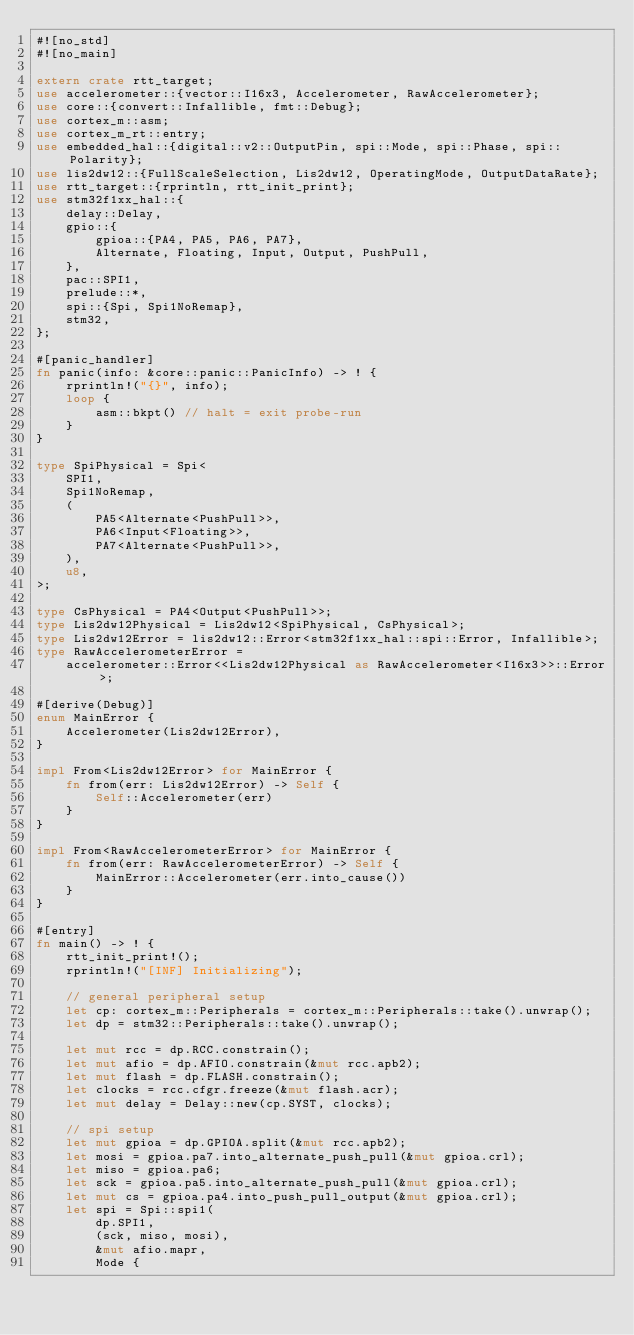Convert code to text. <code><loc_0><loc_0><loc_500><loc_500><_Rust_>#![no_std]
#![no_main]

extern crate rtt_target;
use accelerometer::{vector::I16x3, Accelerometer, RawAccelerometer};
use core::{convert::Infallible, fmt::Debug};
use cortex_m::asm;
use cortex_m_rt::entry;
use embedded_hal::{digital::v2::OutputPin, spi::Mode, spi::Phase, spi::Polarity};
use lis2dw12::{FullScaleSelection, Lis2dw12, OperatingMode, OutputDataRate};
use rtt_target::{rprintln, rtt_init_print};
use stm32f1xx_hal::{
    delay::Delay,
    gpio::{
        gpioa::{PA4, PA5, PA6, PA7},
        Alternate, Floating, Input, Output, PushPull,
    },
    pac::SPI1,
    prelude::*,
    spi::{Spi, Spi1NoRemap},
    stm32,
};

#[panic_handler]
fn panic(info: &core::panic::PanicInfo) -> ! {
    rprintln!("{}", info);
    loop {
        asm::bkpt() // halt = exit probe-run
    }
}

type SpiPhysical = Spi<
    SPI1,
    Spi1NoRemap,
    (
        PA5<Alternate<PushPull>>,
        PA6<Input<Floating>>,
        PA7<Alternate<PushPull>>,
    ),
    u8,
>;

type CsPhysical = PA4<Output<PushPull>>;
type Lis2dw12Physical = Lis2dw12<SpiPhysical, CsPhysical>;
type Lis2dw12Error = lis2dw12::Error<stm32f1xx_hal::spi::Error, Infallible>;
type RawAccelerometerError =
    accelerometer::Error<<Lis2dw12Physical as RawAccelerometer<I16x3>>::Error>;

#[derive(Debug)]
enum MainError {
    Accelerometer(Lis2dw12Error),
}

impl From<Lis2dw12Error> for MainError {
    fn from(err: Lis2dw12Error) -> Self {
        Self::Accelerometer(err)
    }
}

impl From<RawAccelerometerError> for MainError {
    fn from(err: RawAccelerometerError) -> Self {
        MainError::Accelerometer(err.into_cause())
    }
}

#[entry]
fn main() -> ! {
    rtt_init_print!();
    rprintln!("[INF] Initializing");

    // general peripheral setup
    let cp: cortex_m::Peripherals = cortex_m::Peripherals::take().unwrap();
    let dp = stm32::Peripherals::take().unwrap();

    let mut rcc = dp.RCC.constrain();
    let mut afio = dp.AFIO.constrain(&mut rcc.apb2);
    let mut flash = dp.FLASH.constrain();
    let clocks = rcc.cfgr.freeze(&mut flash.acr);
    let mut delay = Delay::new(cp.SYST, clocks);

    // spi setup
    let mut gpioa = dp.GPIOA.split(&mut rcc.apb2);
    let mosi = gpioa.pa7.into_alternate_push_pull(&mut gpioa.crl);
    let miso = gpioa.pa6;
    let sck = gpioa.pa5.into_alternate_push_pull(&mut gpioa.crl);
    let mut cs = gpioa.pa4.into_push_pull_output(&mut gpioa.crl);
    let spi = Spi::spi1(
        dp.SPI1,
        (sck, miso, mosi),
        &mut afio.mapr,
        Mode {</code> 